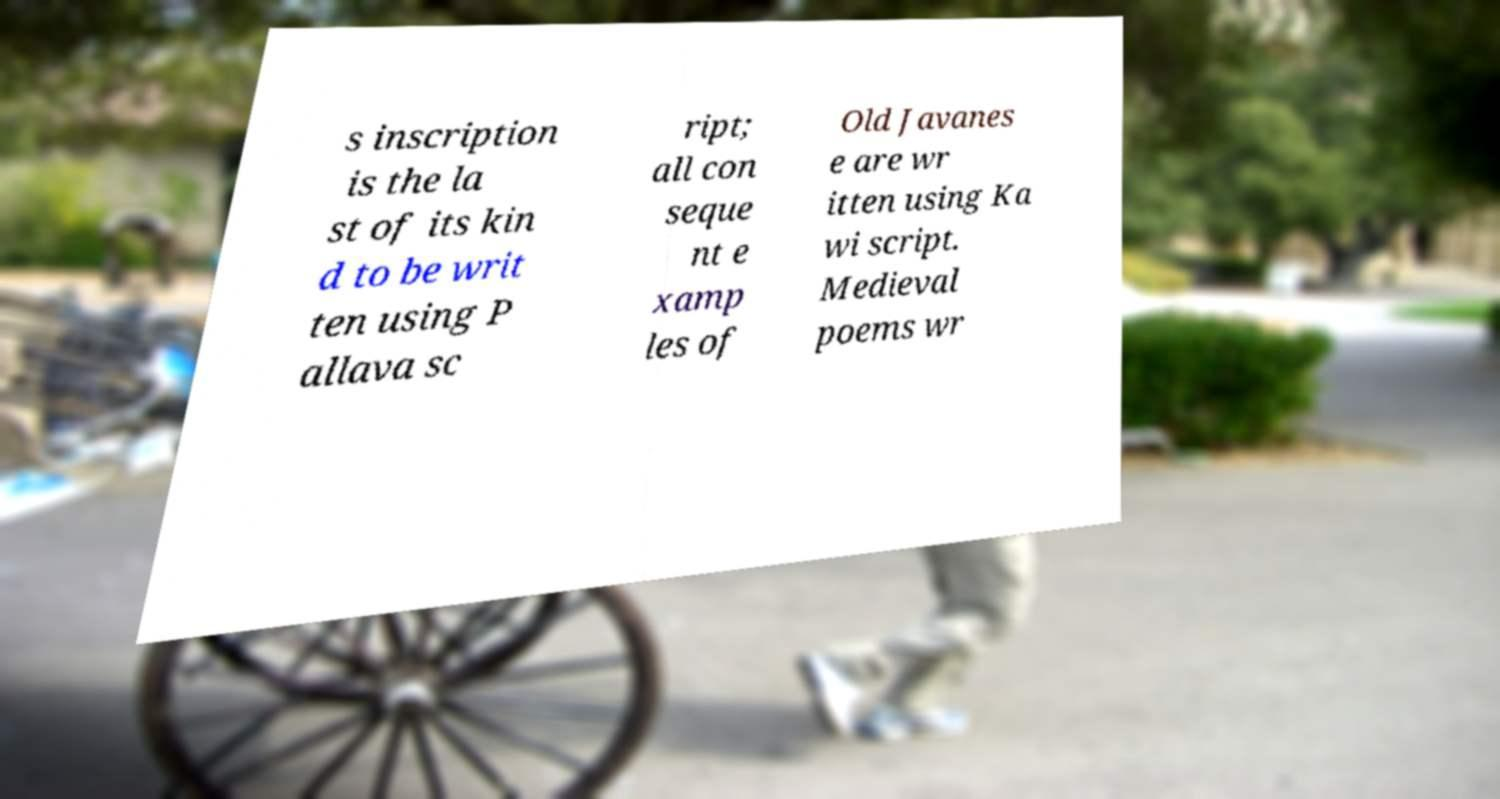Can you read and provide the text displayed in the image?This photo seems to have some interesting text. Can you extract and type it out for me? s inscription is the la st of its kin d to be writ ten using P allava sc ript; all con seque nt e xamp les of Old Javanes e are wr itten using Ka wi script. Medieval poems wr 